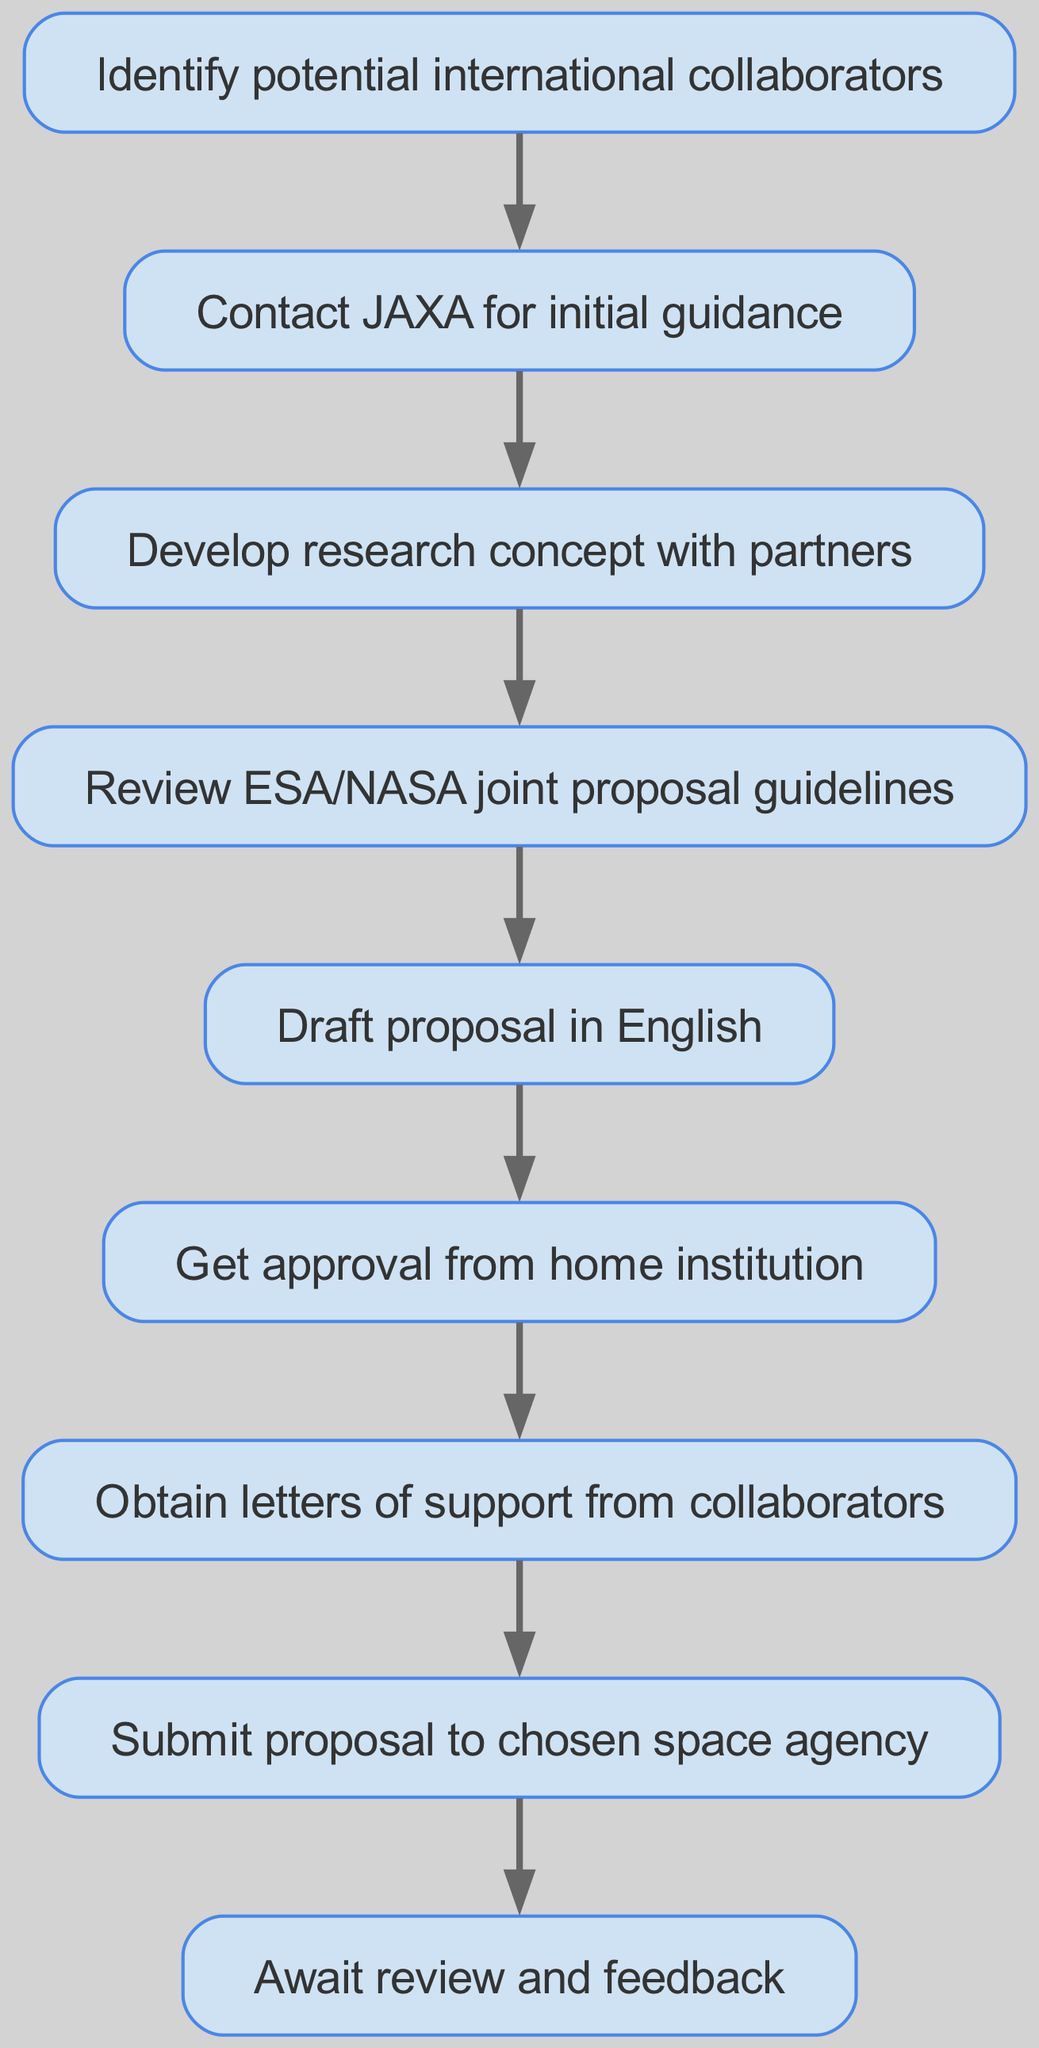What is the first step in the workflow? The first step in the workflow is identified by the first node, which states "Identify potential international collaborators". This is the starting point of the proposed instructions.
Answer: Identify potential international collaborators How many nodes are present in the diagram? The total number of nodes can be counted by reviewing each element in the diagram, and there are nine distinct nodes listed, each representing a step in the workflow.
Answer: Nine What is the last step before submitting the proposal? The node prior to the submission node is "Obtain letters of support from collaborators", which indicates the necessary action to be taken before the final submission to the space agency.
Answer: Obtain letters of support from collaborators Which node involves contacting JAXA? The node that involves contacting JAXA is labeled "Contact JAXA for initial guidance". It is the second step in the workflow and is crucial for obtaining initial support.
Answer: Contact JAXA for initial guidance What is the progression from developing a research concept to submitting the proposal? The progression involves the following steps: First, "Develop research concept with partners" leads to "Review ESA/NASA joint proposal guidelines", which then leads to "Draft proposal in English", followed by "Get approval from home institution", leading to "Obtain letters of support from collaborators", and finally reaching "Submit proposal to chosen space agency". This summarizes the necessary steps from concept development to submission.
Answer: Develop research concept with partners to Submit proposal to chosen space agency What does the workflow require before drafting the proposal? Before drafting the proposal, the workflow specifically requires reviewing the "ESA/NASA joint proposal guidelines". This implies that understanding these guidelines is essential before putting the proposal together.
Answer: Review ESA/NASA joint proposal guidelines What action follows obtaining letters of support? After obtaining letters of support from collaborators, the action that follows is to "Submit proposal to chosen space agency", indicating the next step in the workflow sequence.
Answer: Submit proposal to chosen space agency Which node has no outgoing edges? The node "Await review and feedback" has no outgoing edges, indicating that this is the final step where the process concludes pending the response from the space agency after submission.
Answer: Await review and feedback What is the main purpose of the workflow? The main purpose of the workflow is to provide a sequence of actions necessary for submitting a joint research proposal to a global space agency, facilitating international space collaboration.
Answer: Submitting a joint research proposal 